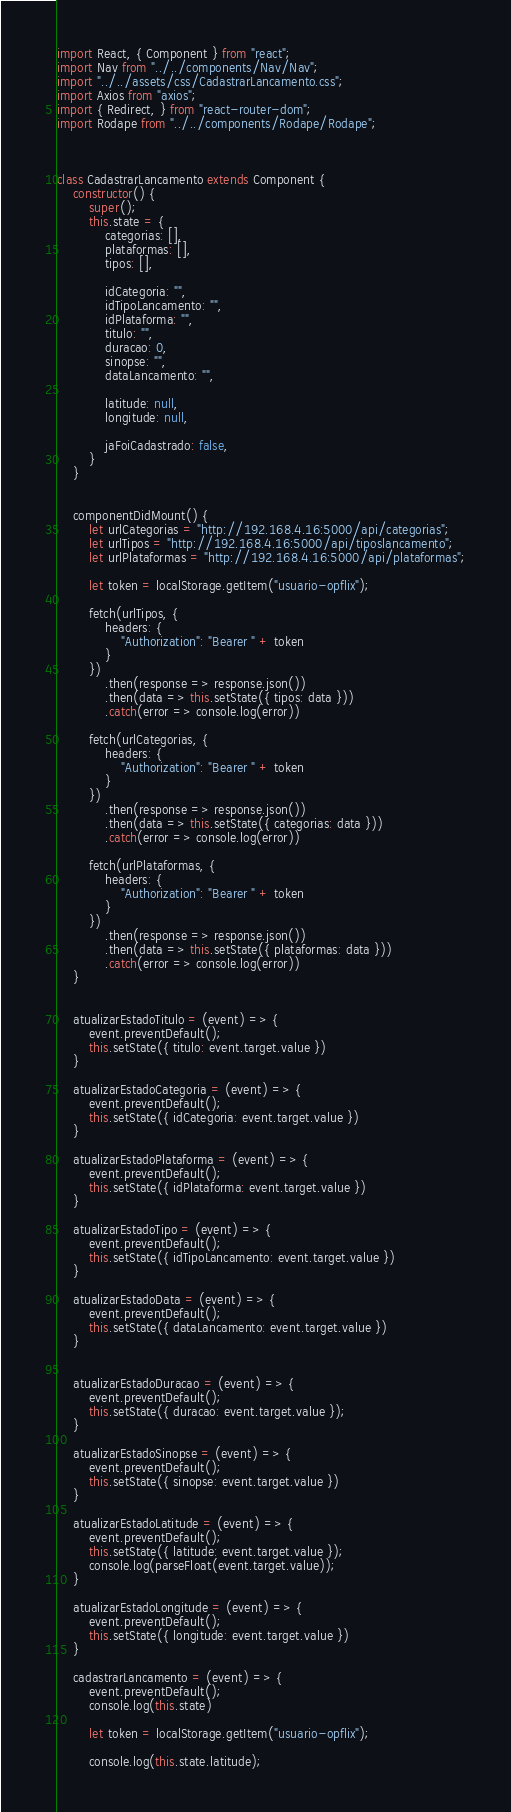Convert code to text. <code><loc_0><loc_0><loc_500><loc_500><_JavaScript_>import React, { Component } from "react";
import Nav from "../../components/Nav/Nav";
import "../../assets/css/CadastrarLancamento.css";
import Axios from "axios";
import { Redirect, } from "react-router-dom";
import Rodape from "../../components/Rodape/Rodape";



class CadastrarLancamento extends Component {
    constructor() {
        super();
        this.state = {
            categorias: [],
            plataformas: [],
            tipos: [],

            idCategoria: "",
            idTipoLancamento: "",
            idPlataforma: "",
            titulo: "",
            duracao: 0,
            sinopse: "",
            dataLancamento: "",

            latitude: null,
            longitude: null,

            jaFoiCadastrado: false,
        }
    }


    componentDidMount() {
        let urlCategorias = "http://192.168.4.16:5000/api/categorias";
        let urlTipos = "http://192.168.4.16:5000/api/tiposlancamento";
        let urlPlataformas = "http://192.168.4.16:5000/api/plataformas";

        let token = localStorage.getItem("usuario-opflix");

        fetch(urlTipos, {
            headers: {
                "Authorization": "Bearer " + token
            }
        })
            .then(response => response.json())
            .then(data => this.setState({ tipos: data }))
            .catch(error => console.log(error))

        fetch(urlCategorias, {
            headers: {
                "Authorization": "Bearer " + token
            }
        })
            .then(response => response.json())
            .then(data => this.setState({ categorias: data }))
            .catch(error => console.log(error))

        fetch(urlPlataformas, {
            headers: {
                "Authorization": "Bearer " + token
            }
        })
            .then(response => response.json())
            .then(data => this.setState({ plataformas: data }))
            .catch(error => console.log(error))
    }


    atualizarEstadoTitulo = (event) => {
        event.preventDefault();
        this.setState({ titulo: event.target.value })
    }

    atualizarEstadoCategoria = (event) => {
        event.preventDefault();
        this.setState({ idCategoria: event.target.value })
    }

    atualizarEstadoPlataforma = (event) => {
        event.preventDefault();
        this.setState({ idPlataforma: event.target.value })
    }

    atualizarEstadoTipo = (event) => {
        event.preventDefault();
        this.setState({ idTipoLancamento: event.target.value })
    }

    atualizarEstadoData = (event) => {
        event.preventDefault();
        this.setState({ dataLancamento: event.target.value })
    }


    atualizarEstadoDuracao = (event) => {
        event.preventDefault();
        this.setState({ duracao: event.target.value });
    }

    atualizarEstadoSinopse = (event) => {
        event.preventDefault();
        this.setState({ sinopse: event.target.value })
    }

    atualizarEstadoLatitude = (event) => {
        event.preventDefault();
        this.setState({ latitude: event.target.value });
        console.log(parseFloat(event.target.value));
    }

    atualizarEstadoLongitude = (event) => {
        event.preventDefault();
        this.setState({ longitude: event.target.value })
    }

    cadastrarLancamento = (event) => {
        event.preventDefault();
        console.log(this.state)

        let token = localStorage.getItem("usuario-opflix");
        
        console.log(this.state.latitude);</code> 